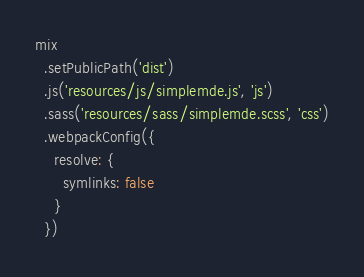Convert code to text. <code><loc_0><loc_0><loc_500><loc_500><_JavaScript_>
mix
  .setPublicPath('dist')
  .js('resources/js/simplemde.js', 'js')
  .sass('resources/sass/simplemde.scss', 'css')
  .webpackConfig({
    resolve: {
      symlinks: false
    }
  })
</code> 